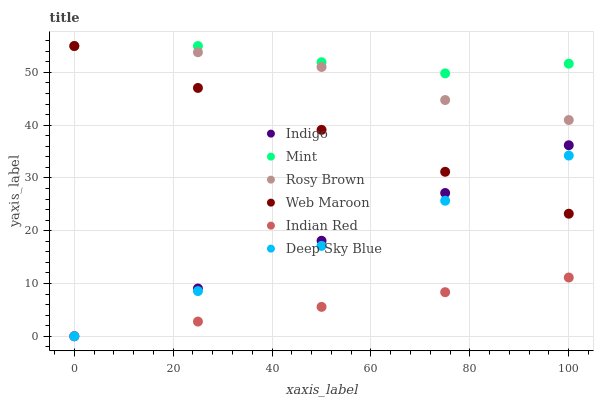Does Indian Red have the minimum area under the curve?
Answer yes or no. Yes. Does Mint have the maximum area under the curve?
Answer yes or no. Yes. Does Deep Sky Blue have the minimum area under the curve?
Answer yes or no. No. Does Deep Sky Blue have the maximum area under the curve?
Answer yes or no. No. Is Indigo the smoothest?
Answer yes or no. Yes. Is Mint the roughest?
Answer yes or no. Yes. Is Deep Sky Blue the smoothest?
Answer yes or no. No. Is Deep Sky Blue the roughest?
Answer yes or no. No. Does Indigo have the lowest value?
Answer yes or no. Yes. Does Rosy Brown have the lowest value?
Answer yes or no. No. Does Mint have the highest value?
Answer yes or no. Yes. Does Deep Sky Blue have the highest value?
Answer yes or no. No. Is Indigo less than Mint?
Answer yes or no. Yes. Is Mint greater than Indigo?
Answer yes or no. Yes. Does Rosy Brown intersect Mint?
Answer yes or no. Yes. Is Rosy Brown less than Mint?
Answer yes or no. No. Is Rosy Brown greater than Mint?
Answer yes or no. No. Does Indigo intersect Mint?
Answer yes or no. No. 